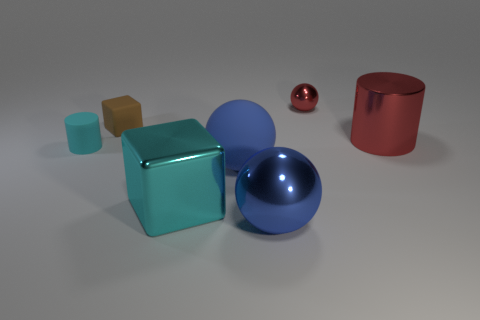Add 3 big cyan metallic things. How many objects exist? 10 Subtract all cylinders. How many objects are left? 5 Add 5 small purple cylinders. How many small purple cylinders exist? 5 Subtract 0 purple balls. How many objects are left? 7 Subtract all tiny blue shiny balls. Subtract all cyan blocks. How many objects are left? 6 Add 4 red cylinders. How many red cylinders are left? 5 